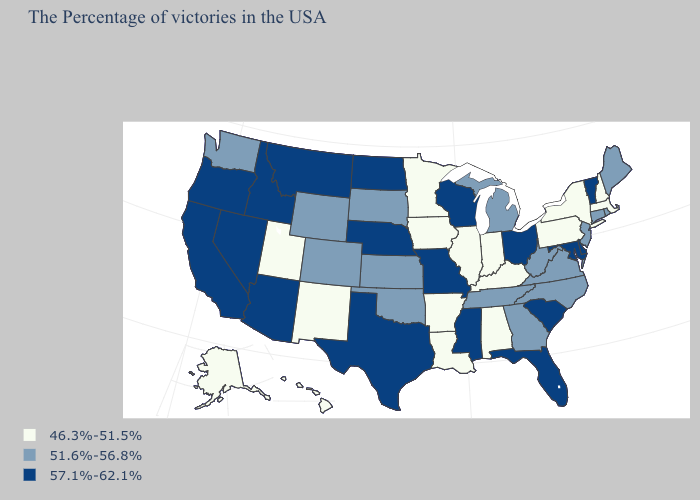Does Hawaii have the lowest value in the West?
Answer briefly. Yes. Name the states that have a value in the range 46.3%-51.5%?
Concise answer only. Massachusetts, New Hampshire, New York, Pennsylvania, Kentucky, Indiana, Alabama, Illinois, Louisiana, Arkansas, Minnesota, Iowa, New Mexico, Utah, Alaska, Hawaii. Does Kansas have a lower value than South Carolina?
Concise answer only. Yes. What is the value of South Dakota?
Concise answer only. 51.6%-56.8%. Which states have the lowest value in the West?
Keep it brief. New Mexico, Utah, Alaska, Hawaii. Does Michigan have the lowest value in the USA?
Concise answer only. No. Among the states that border Pennsylvania , which have the lowest value?
Answer briefly. New York. What is the value of Michigan?
Short answer required. 51.6%-56.8%. Which states have the lowest value in the USA?
Be succinct. Massachusetts, New Hampshire, New York, Pennsylvania, Kentucky, Indiana, Alabama, Illinois, Louisiana, Arkansas, Minnesota, Iowa, New Mexico, Utah, Alaska, Hawaii. What is the highest value in states that border Montana?
Short answer required. 57.1%-62.1%. Which states hav the highest value in the West?
Short answer required. Montana, Arizona, Idaho, Nevada, California, Oregon. Does Delaware have the lowest value in the USA?
Keep it brief. No. Name the states that have a value in the range 57.1%-62.1%?
Concise answer only. Vermont, Delaware, Maryland, South Carolina, Ohio, Florida, Wisconsin, Mississippi, Missouri, Nebraska, Texas, North Dakota, Montana, Arizona, Idaho, Nevada, California, Oregon. Does Wyoming have the lowest value in the USA?
Quick response, please. No. Name the states that have a value in the range 57.1%-62.1%?
Concise answer only. Vermont, Delaware, Maryland, South Carolina, Ohio, Florida, Wisconsin, Mississippi, Missouri, Nebraska, Texas, North Dakota, Montana, Arizona, Idaho, Nevada, California, Oregon. 